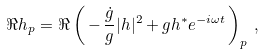Convert formula to latex. <formula><loc_0><loc_0><loc_500><loc_500>\Re h _ { p } = \Re \left ( \, - \, \frac { \dot { g } } { g } | h | ^ { 2 } + g h ^ { * } e ^ { - i \omega t } \, \right ) _ { p } \, ,</formula> 